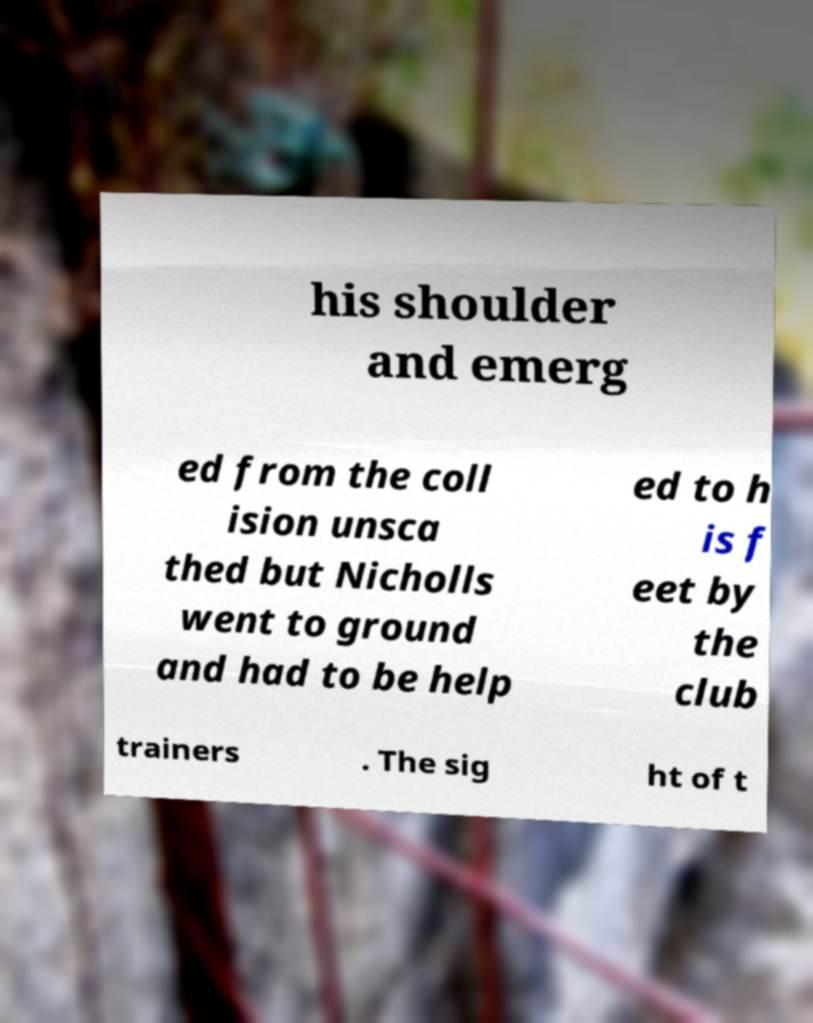What messages or text are displayed in this image? I need them in a readable, typed format. his shoulder and emerg ed from the coll ision unsca thed but Nicholls went to ground and had to be help ed to h is f eet by the club trainers . The sig ht of t 